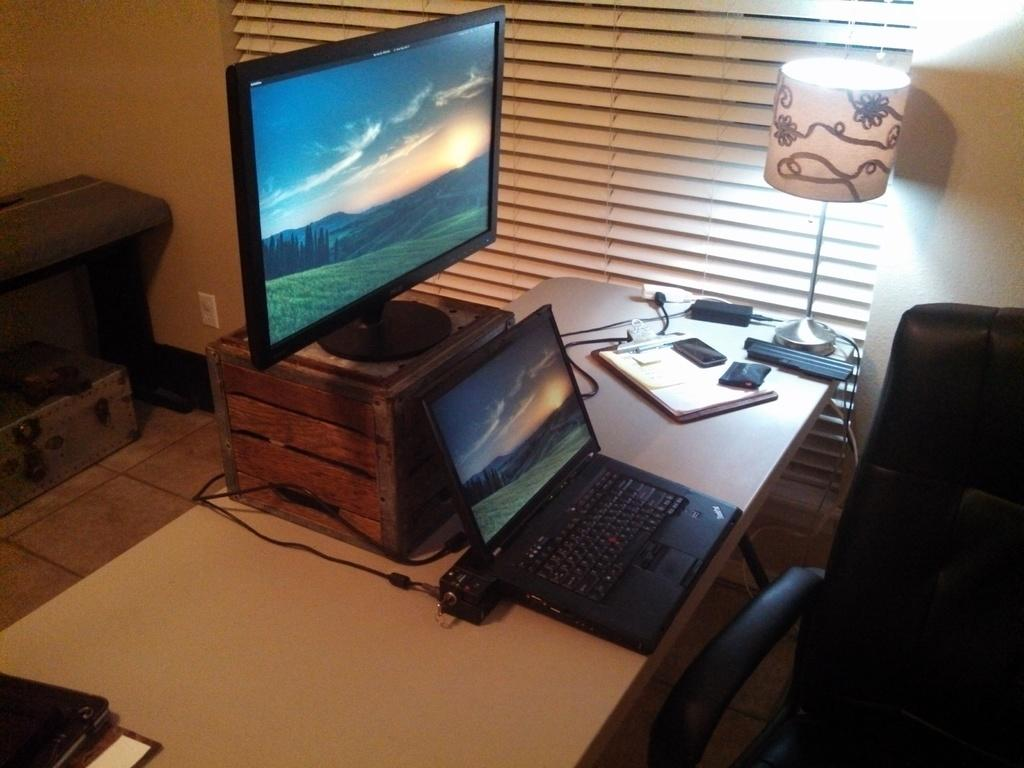What objects are on the table in the image? There is a box, a monitor, a laptop, a pad, papers, mobiles, a lantern lamp, and a cable on the table in the image. What type of furniture is in the room? There is a black chair and a bed in the room. Is there anything under the bed? Yes, there is a box under the bed. Can you describe the maid's outfit in the image? There is no maid present in the image. How does the stranger interact with the objects on the table? There is no stranger present in the image. 